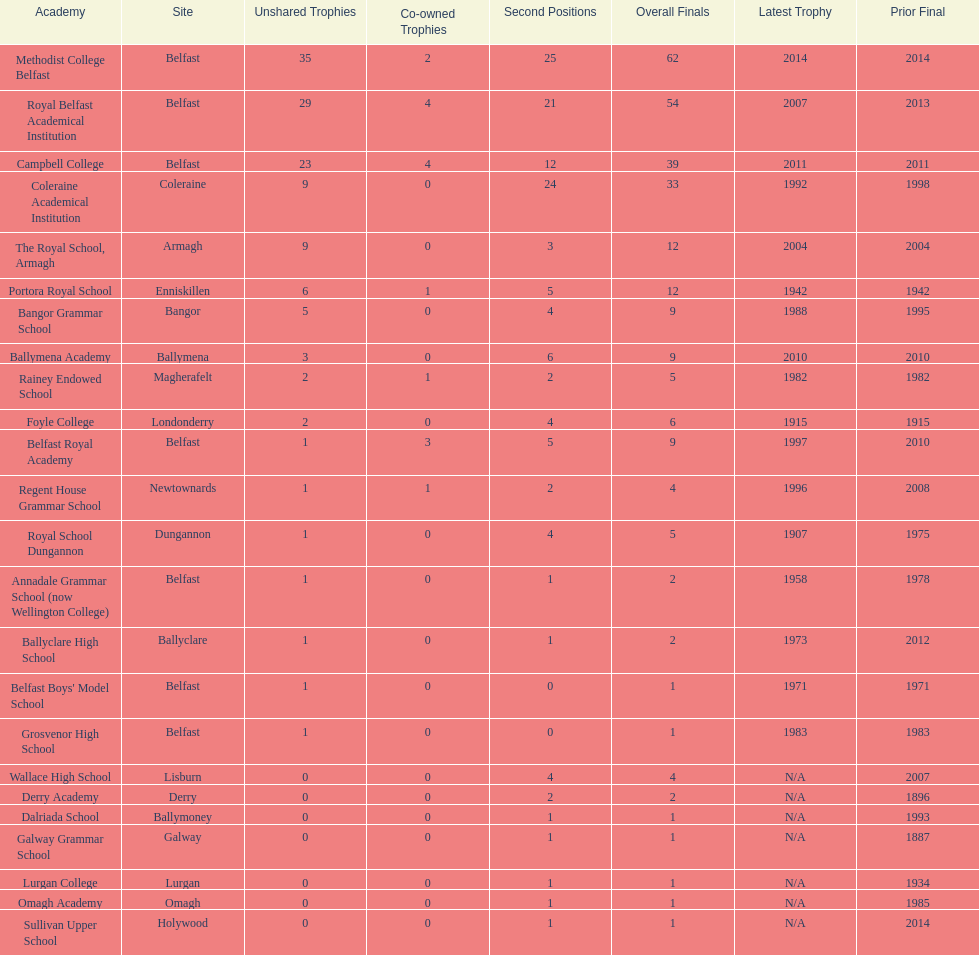What is the difference in runners-up from coleraine academical institution and royal school dungannon? 20. 